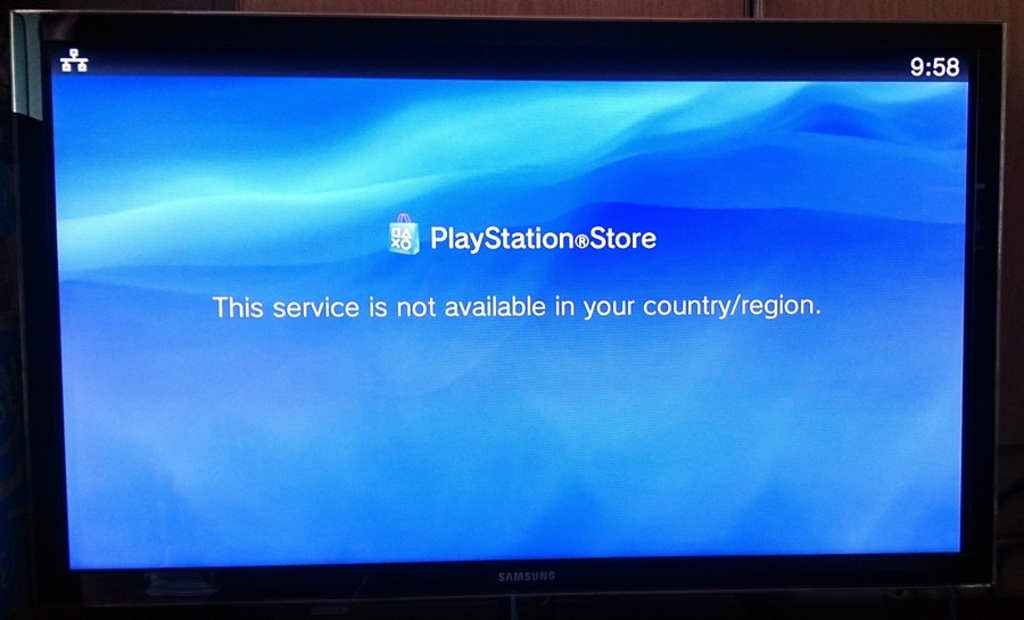What's happening in the scene? The picture shows a television screen displaying an error message from the PlayStation Store, indicating 'This service is not available in your country/region.' The blue gradient on the screen alongside this message suggests a user might have been attempting to access the store, potentially for downloading games or updates, and was met with this geographic restriction. The clock on the display shows it's 9:58, which could imply the person encountered this issue during what might be a typical gaming hour, adding to the frustration of not being able to use the service as intended. 